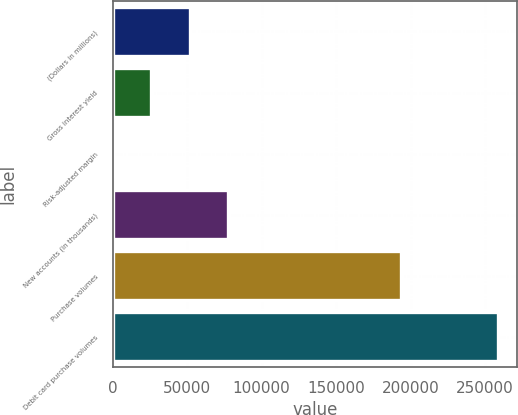<chart> <loc_0><loc_0><loc_500><loc_500><bar_chart><fcel>(Dollars in millions)<fcel>Gross interest yield<fcel>Risk-adjusted margin<fcel>New accounts (in thousands)<fcel>Purchase volumes<fcel>Debit card purchase volumes<nl><fcel>51678.6<fcel>25843.1<fcel>7.54<fcel>77514.2<fcel>193500<fcel>258363<nl></chart> 